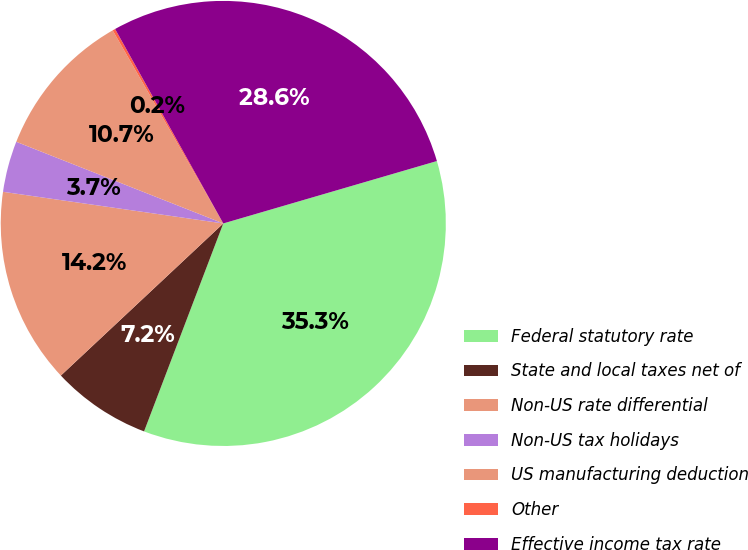Convert chart. <chart><loc_0><loc_0><loc_500><loc_500><pie_chart><fcel>Federal statutory rate<fcel>State and local taxes net of<fcel>Non-US rate differential<fcel>Non-US tax holidays<fcel>US manufacturing deduction<fcel>Other<fcel>Effective income tax rate<nl><fcel>35.32%<fcel>7.23%<fcel>14.25%<fcel>3.71%<fcel>10.74%<fcel>0.2%<fcel>28.56%<nl></chart> 